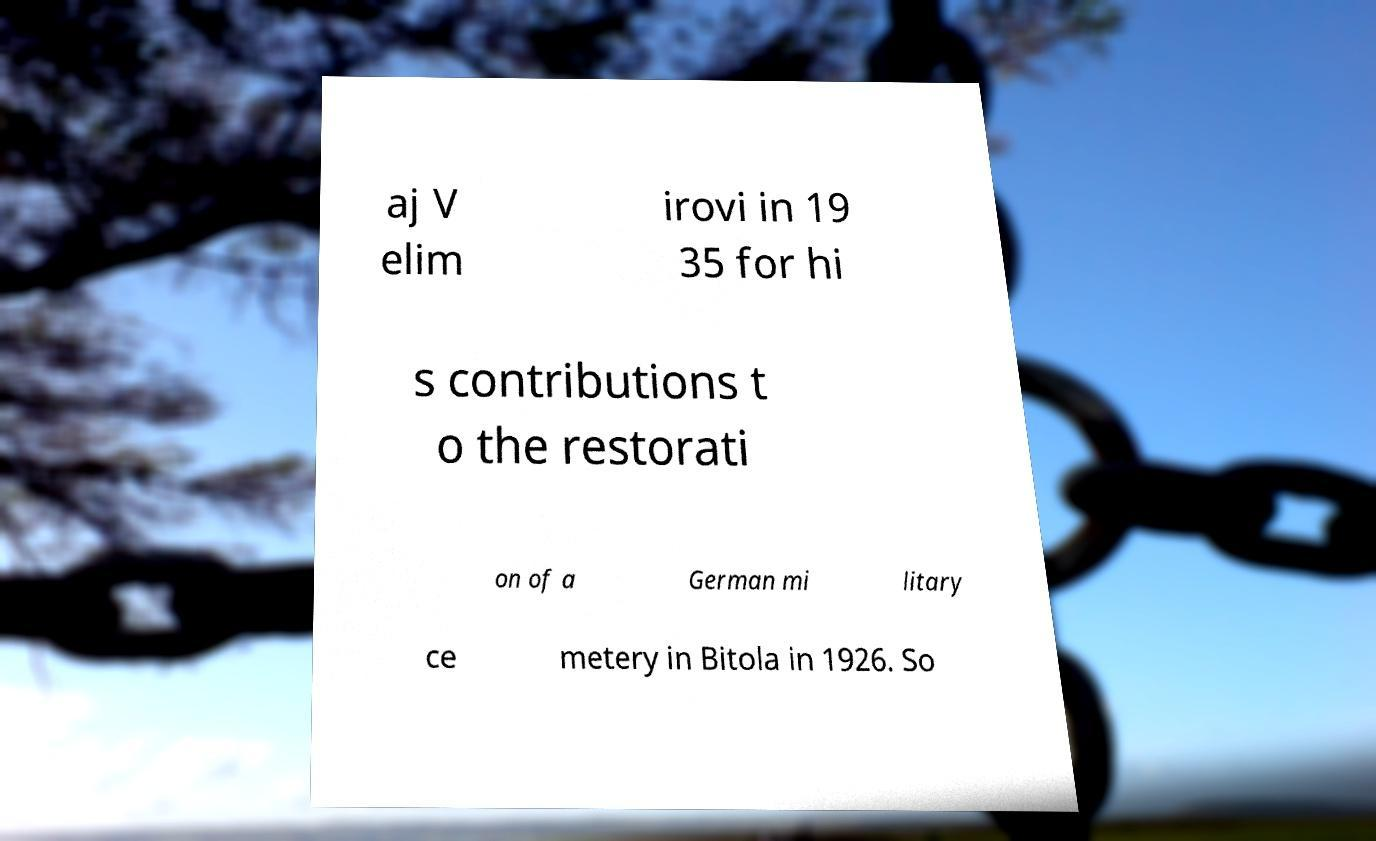What messages or text are displayed in this image? I need them in a readable, typed format. aj V elim irovi in 19 35 for hi s contributions t o the restorati on of a German mi litary ce metery in Bitola in 1926. So 